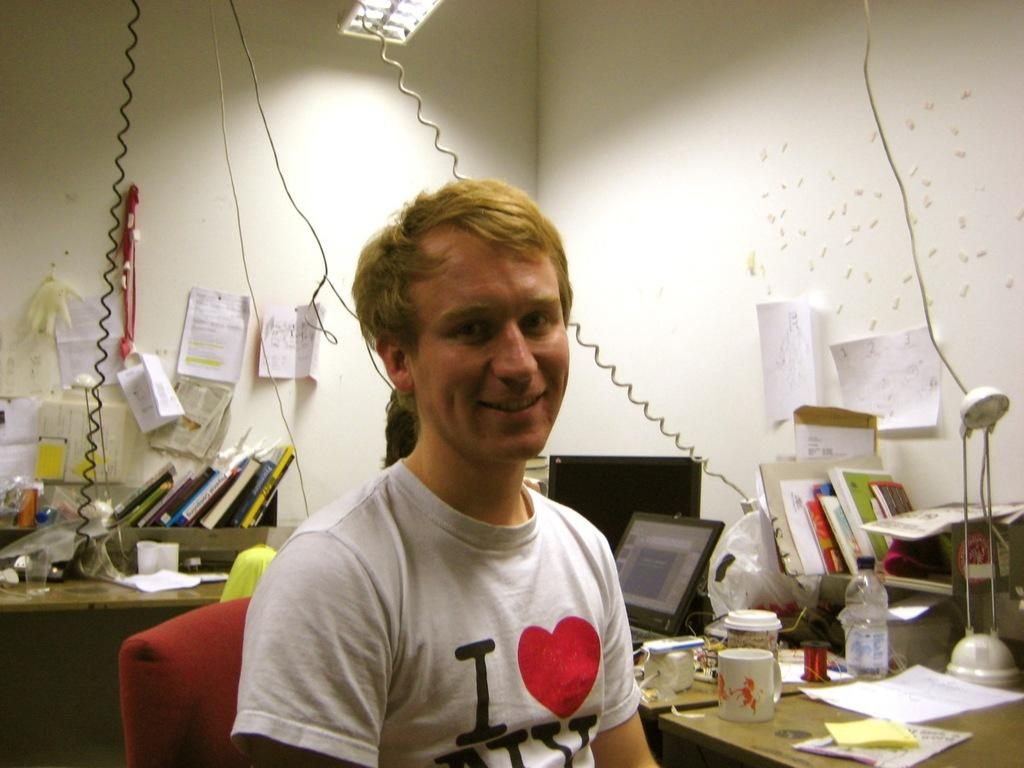<image>
Present a compact description of the photo's key features. A man in an office is wearing an " I Love NY" shirt. 